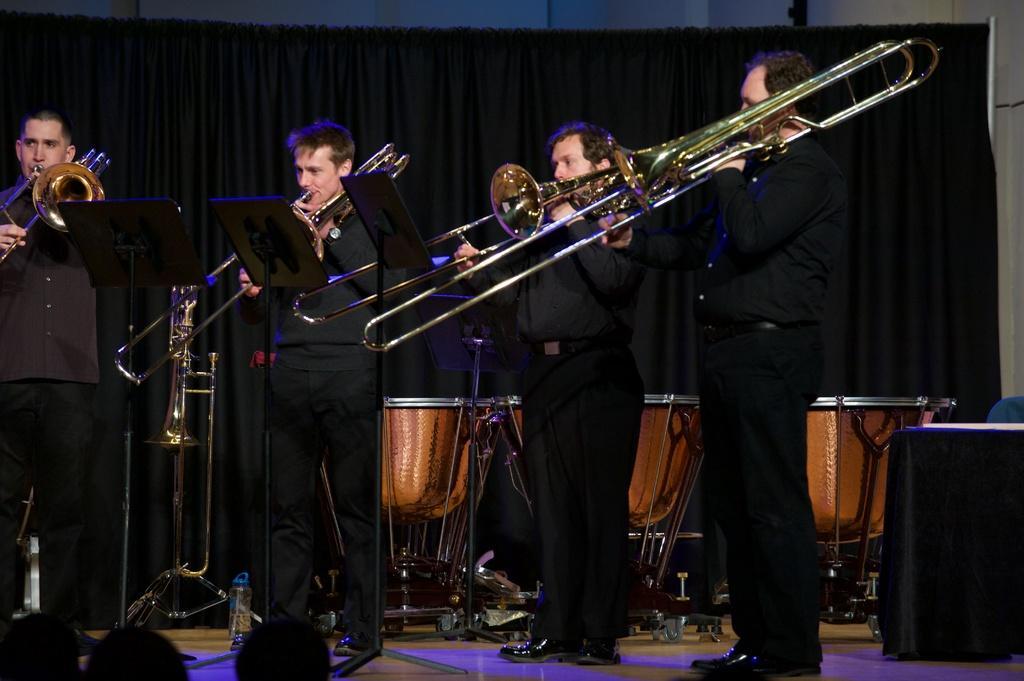Please provide a concise description of this image. The person wearing black dress are playing music, There are audience in front of them and there are drums back of them and the background is black in color. 